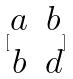Convert formula to latex. <formula><loc_0><loc_0><loc_500><loc_500>[ \begin{matrix} a & b \\ b & d \end{matrix} ]</formula> 